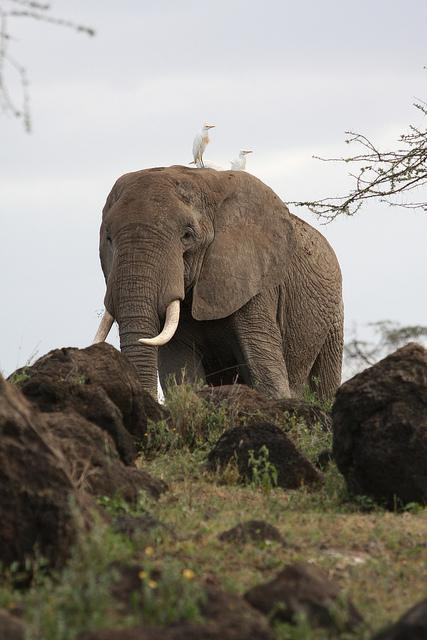What is in front of the elephant's tusks?

Choices:
A) rocks
B) branches
C) bark
D) grass rocks 